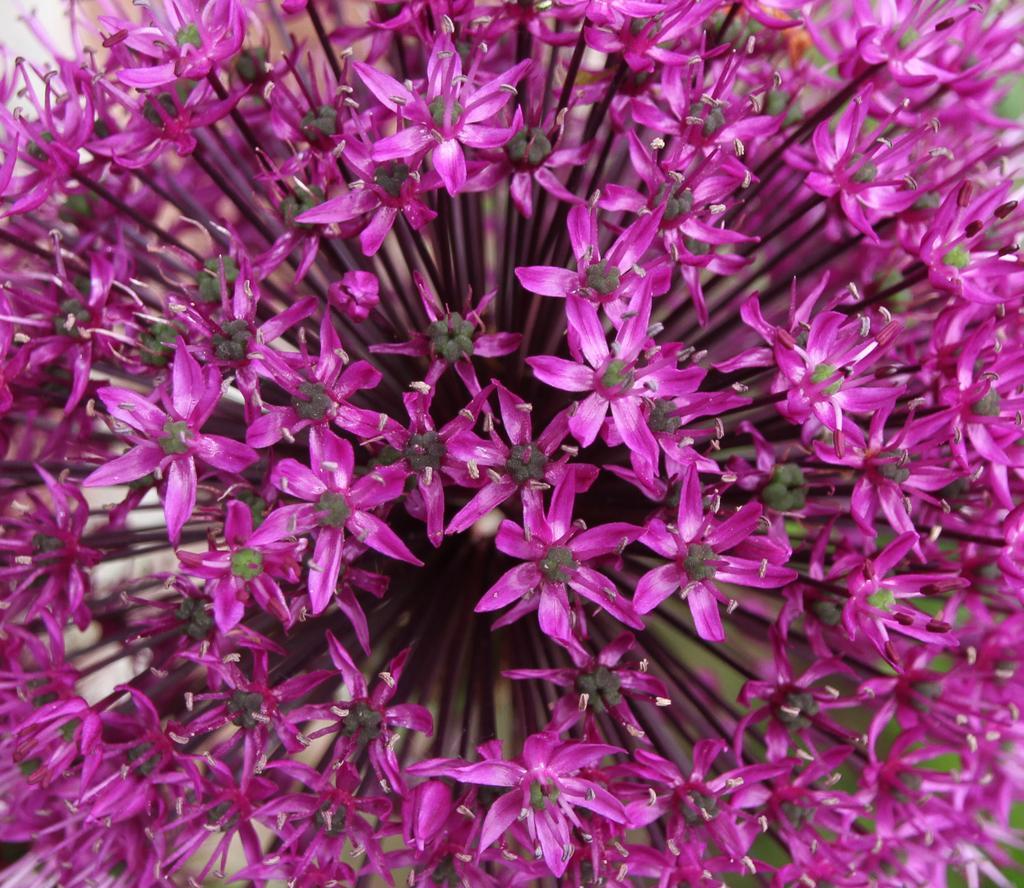How would you summarize this image in a sentence or two? In this picture I can see flowers, and there is blur background. 